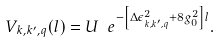<formula> <loc_0><loc_0><loc_500><loc_500>V _ { k , k ^ { \prime } , q } ( l ) = U \ e ^ { - \left [ \Delta \epsilon _ { k , k ^ { \prime } , q } ^ { 2 } + 8 g _ { 0 } ^ { 2 } \right ] l } .</formula> 